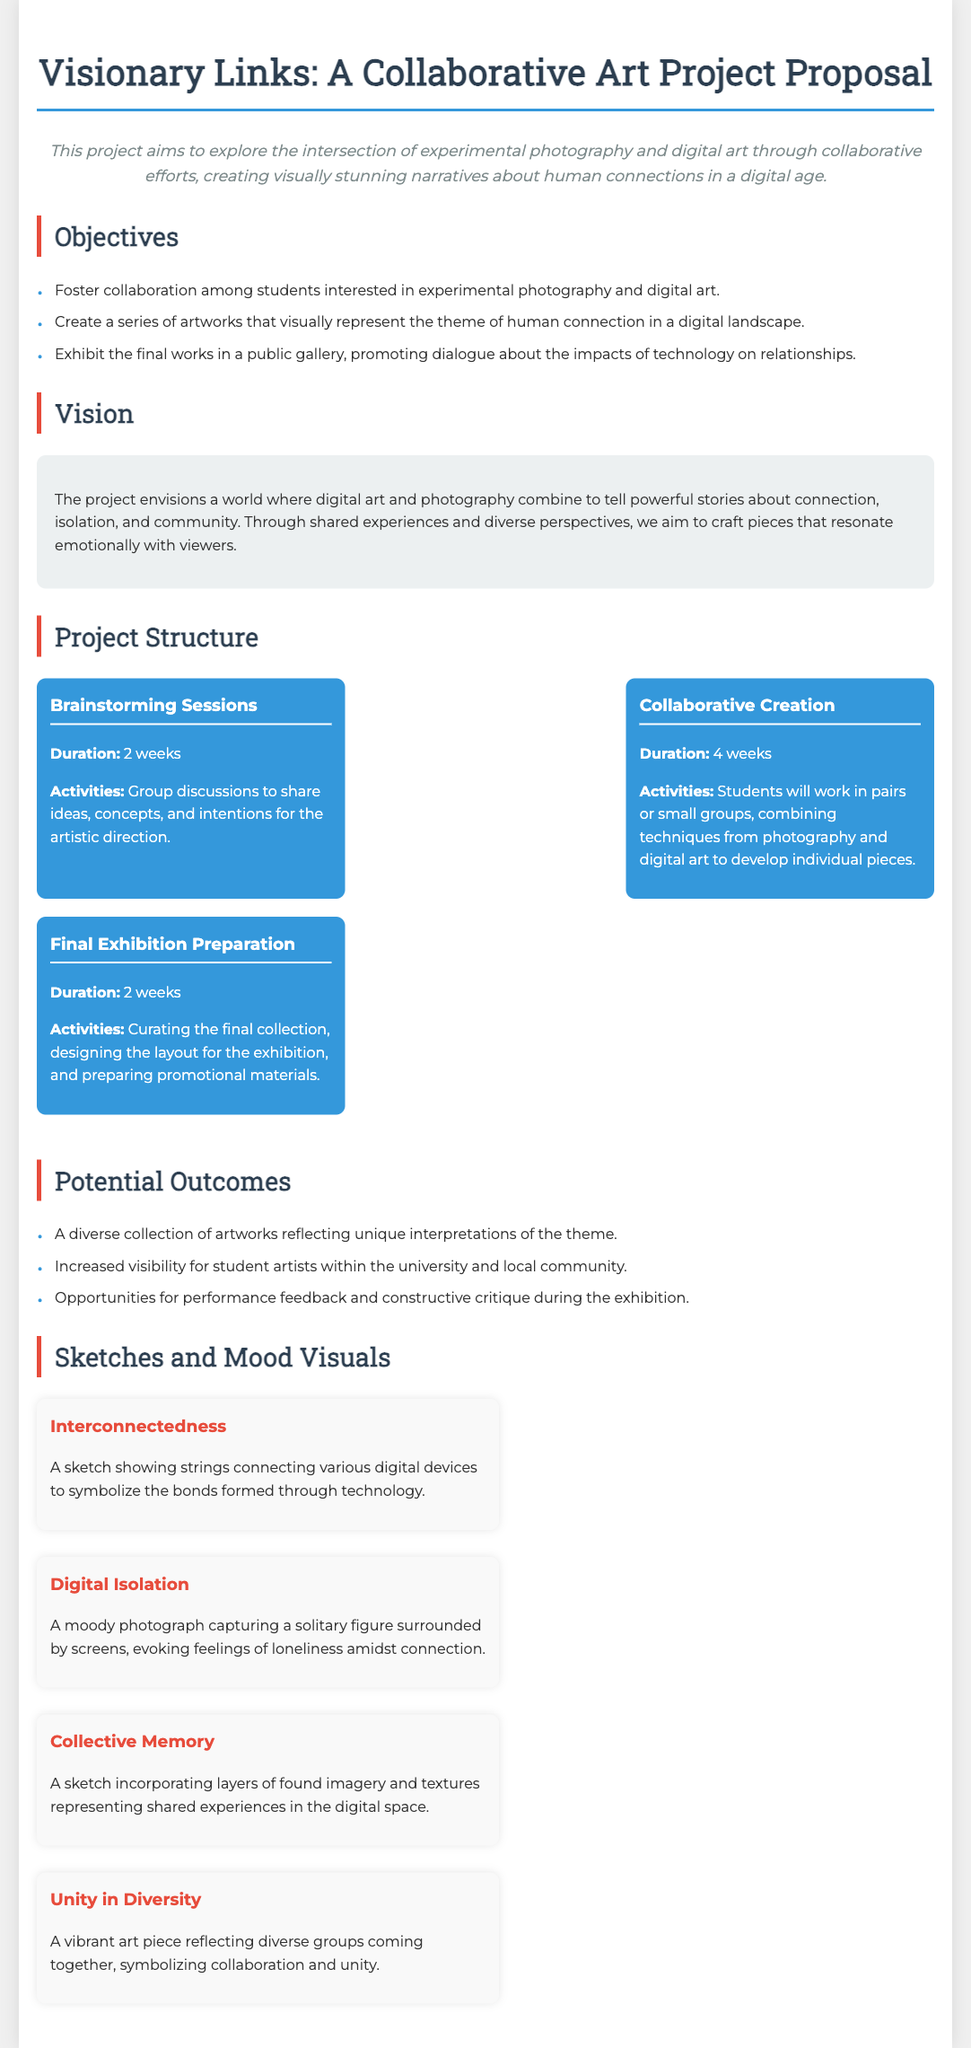What is the title of the project? The title of the project is highlighted at the beginning of the document, and it is "Visionary Links: A Collaborative Art Project Proposal."
Answer: Visionary Links: A Collaborative Art Project Proposal How many weeks are allocated for the collaborative creation phase? The document specifies that the collaborative creation phase lasts for 4 weeks.
Answer: 4 weeks What is the main theme of the artworks being created? The central theme of the artworks produced in this project is described as focusing on "human connection in a digital landscape."
Answer: human connection in a digital landscape Which phase involves curating the final collection? In the document, it is stated that "Final Exhibition Preparation" is the phase where the collection is curated.
Answer: Final Exhibition Preparation Name one potential outcome of the project. The document lists several potential outcomes, one of which is "Increased visibility for student artists within the university and local community."
Answer: Increased visibility for student artists within the university and local community What type of art does the project combine? The document mentions that the project combines "experimental photography and digital art."
Answer: experimental photography and digital art What is the duration of the brainstorming sessions? According to the document, the duration of the brainstorming sessions is stated as 2 weeks.
Answer: 2 weeks Which sketch depicts a moody photograph? "Digital Isolation" is identified in the document as the sketch that showcases a moody photograph capturing solitude.
Answer: Digital Isolation 